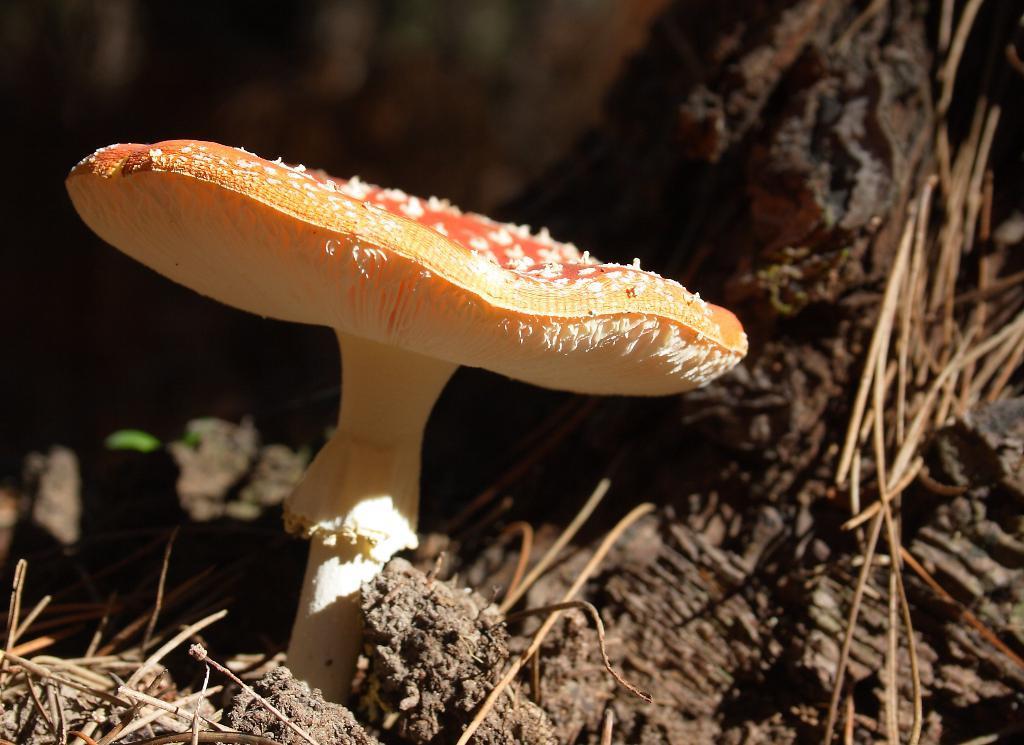Can you describe this image briefly? In this image there is a mushroom, beside that there is a tree and there is some dry grass on the surface. 